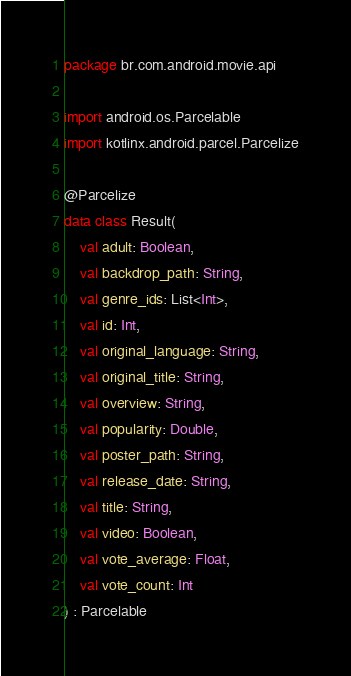<code> <loc_0><loc_0><loc_500><loc_500><_Kotlin_>package br.com.android.movie.api

import android.os.Parcelable
import kotlinx.android.parcel.Parcelize

@Parcelize
data class Result(
    val adult: Boolean,
    val backdrop_path: String,
    val genre_ids: List<Int>,
    val id: Int,
    val original_language: String,
    val original_title: String,
    val overview: String,
    val popularity: Double,
    val poster_path: String,
    val release_date: String,
    val title: String,
    val video: Boolean,
    val vote_average: Float,
    val vote_count: Int
) : Parcelable</code> 